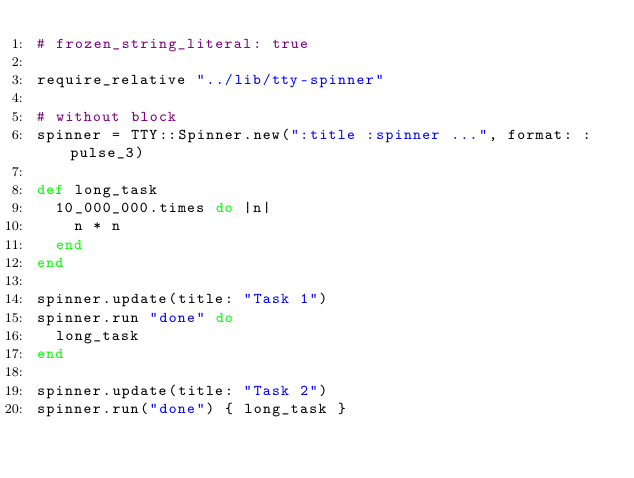<code> <loc_0><loc_0><loc_500><loc_500><_Ruby_># frozen_string_literal: true

require_relative "../lib/tty-spinner"

# without block
spinner = TTY::Spinner.new(":title :spinner ...", format: :pulse_3)

def long_task
  10_000_000.times do |n|
    n * n
  end
end

spinner.update(title: "Task 1")
spinner.run "done" do
  long_task
end

spinner.update(title: "Task 2")
spinner.run("done") { long_task }
</code> 